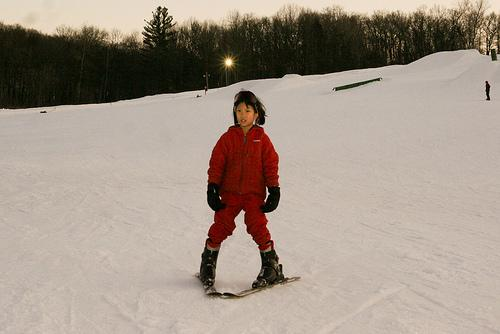What is the child standing on? Please explain your reasoning. snow. The ground is covered in white and she's wearing warm clothing. under her feet are skis. 